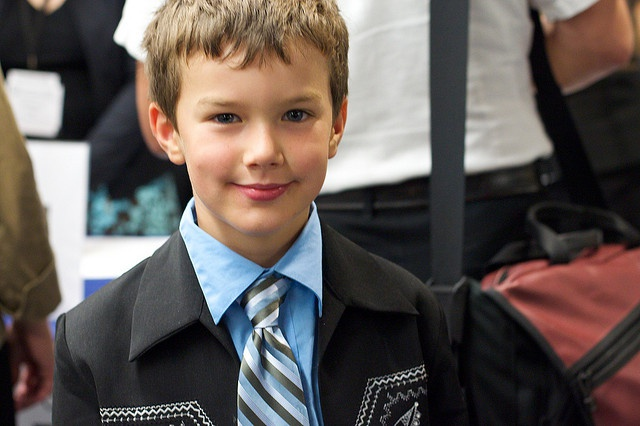Describe the objects in this image and their specific colors. I can see people in black, gray, and tan tones, people in black, lightgray, darkgray, and brown tones, backpack in black, brown, and maroon tones, handbag in black, brown, and maroon tones, and people in black, maroon, gray, and olive tones in this image. 